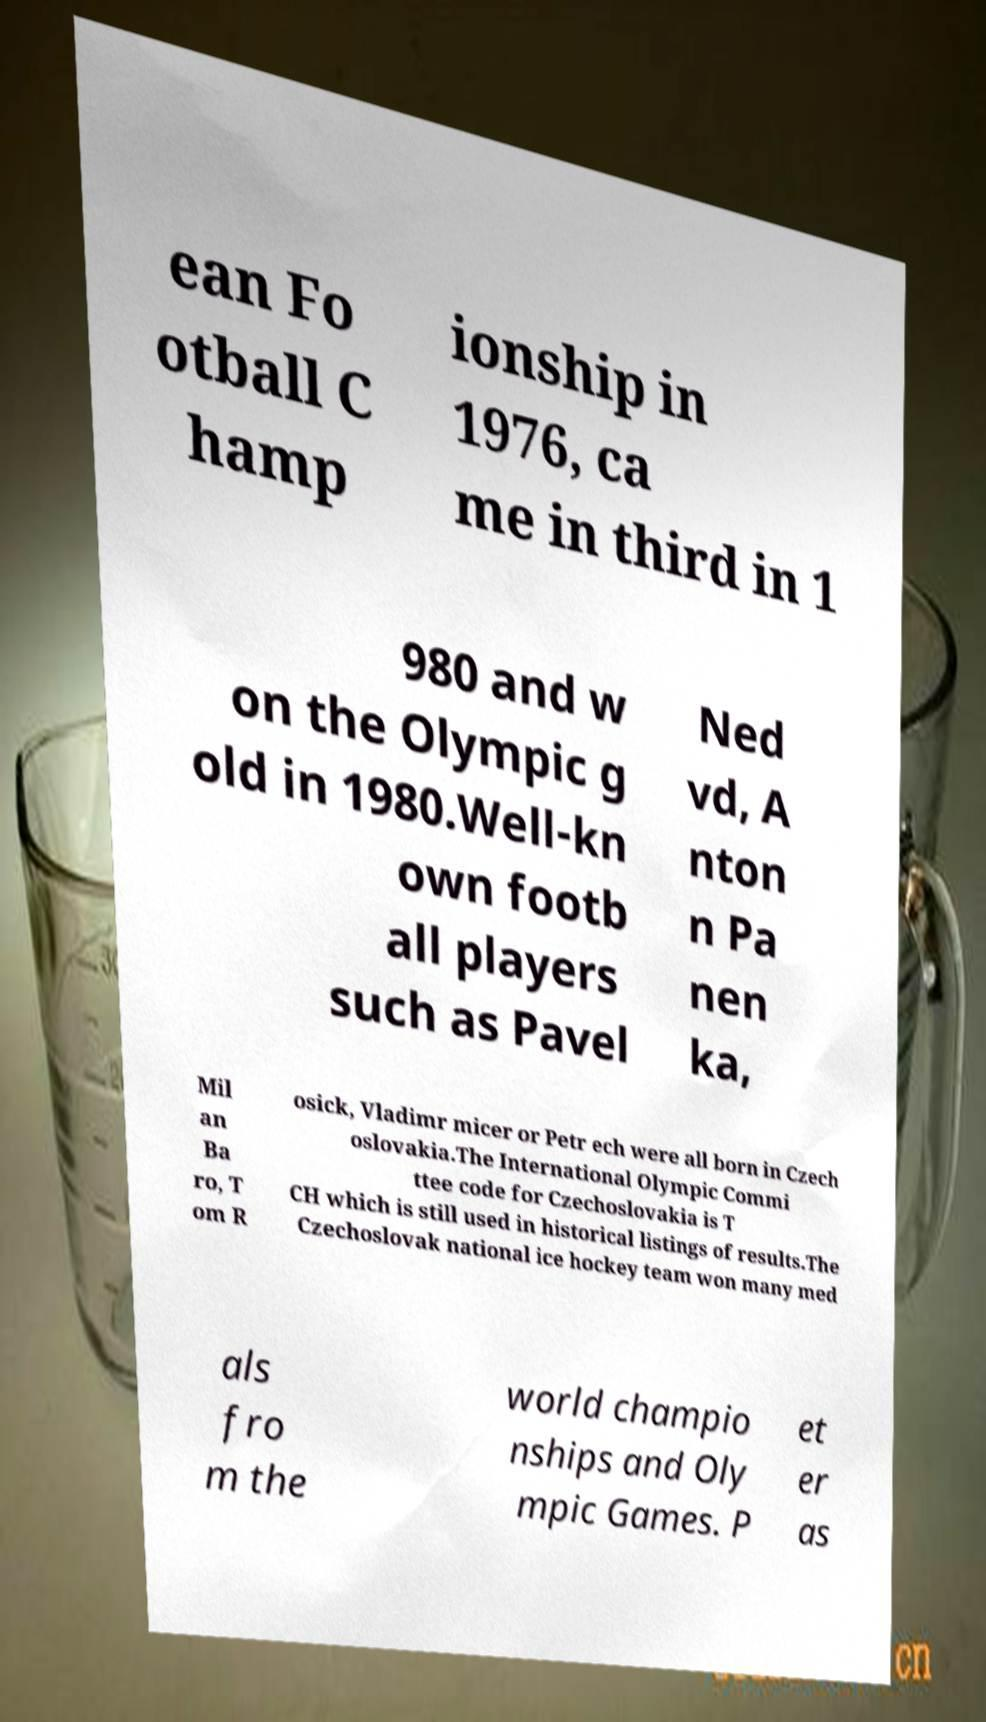I need the written content from this picture converted into text. Can you do that? ean Fo otball C hamp ionship in 1976, ca me in third in 1 980 and w on the Olympic g old in 1980.Well-kn own footb all players such as Pavel Ned vd, A nton n Pa nen ka, Mil an Ba ro, T om R osick, Vladimr micer or Petr ech were all born in Czech oslovakia.The International Olympic Commi ttee code for Czechoslovakia is T CH which is still used in historical listings of results.The Czechoslovak national ice hockey team won many med als fro m the world champio nships and Oly mpic Games. P et er as 